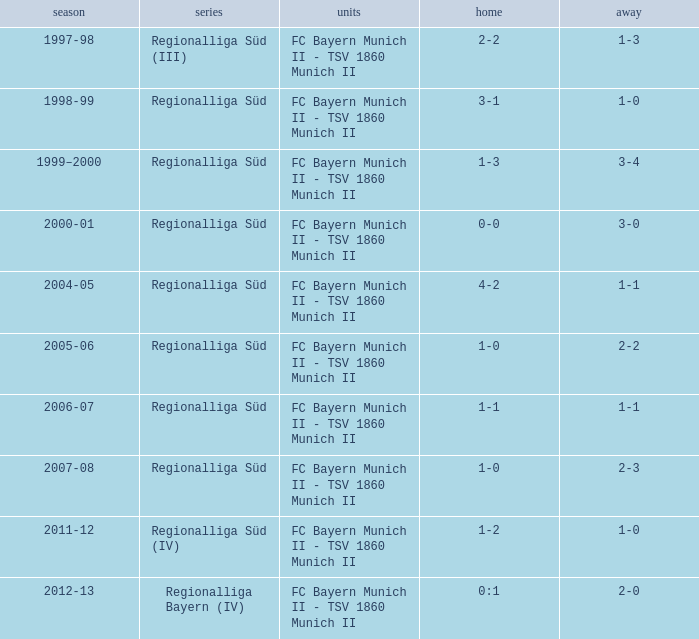What is the league with a 0:1 home? Regionalliga Bayern (IV). 